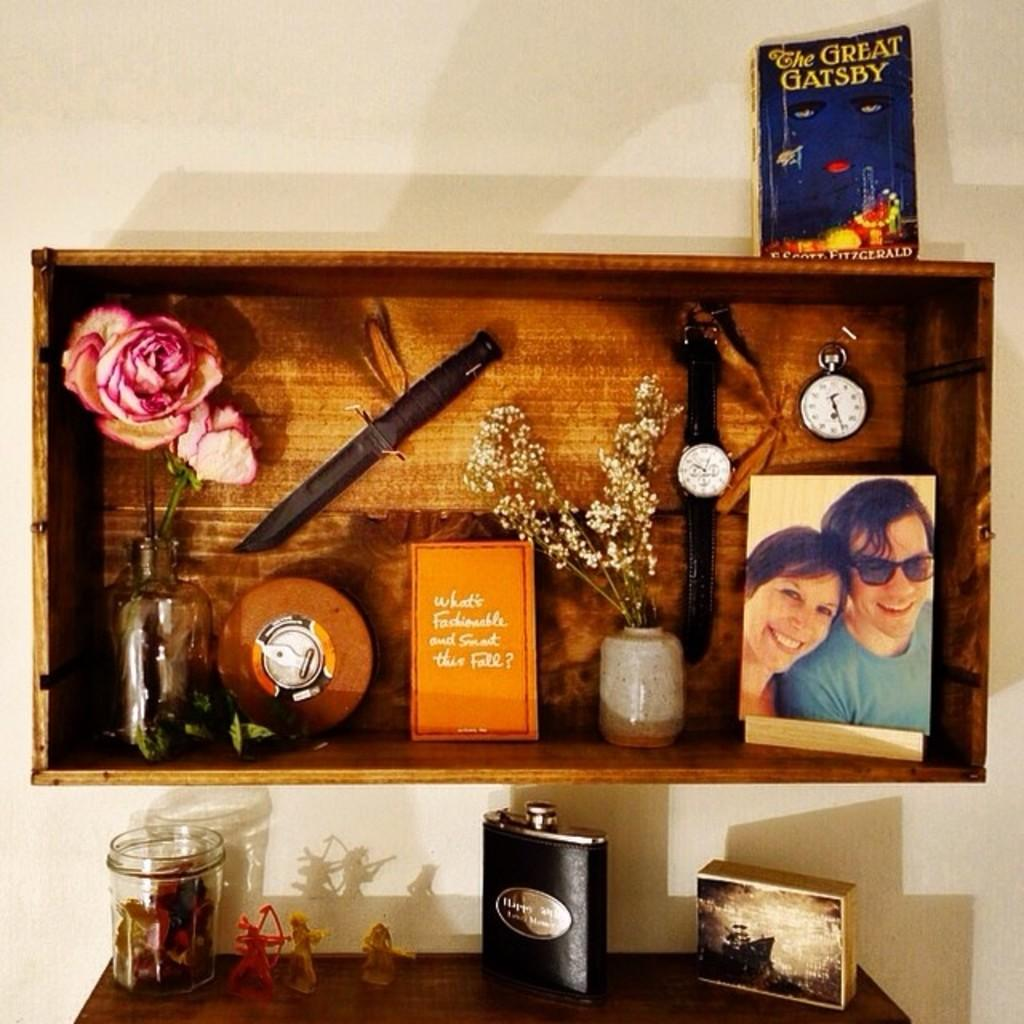<image>
Summarize the visual content of the image. The novel "The Great Gatsby" sits on a shelf above many other items. 